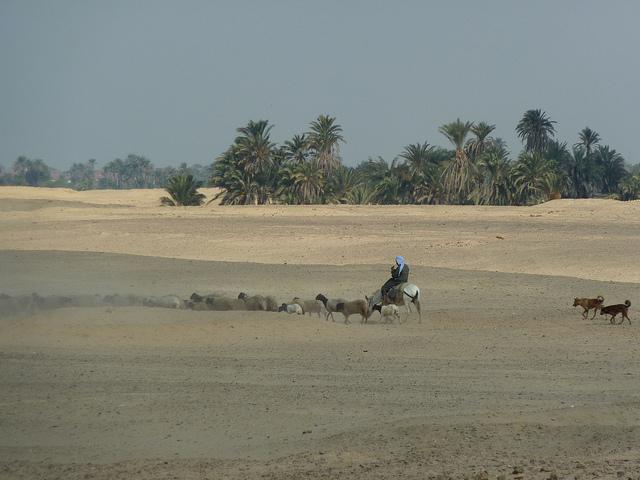Where is the man riding through?

Choices:
A) yard
B) forest
C) desert
D) parking lot desert 